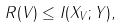<formula> <loc_0><loc_0><loc_500><loc_500>R ( V ) \leq I ( X _ { V } ; Y ) ,</formula> 